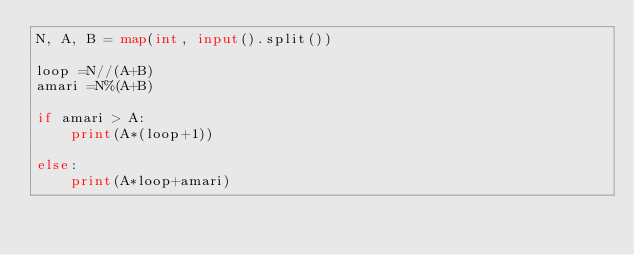Convert code to text. <code><loc_0><loc_0><loc_500><loc_500><_Python_>N, A, B = map(int, input().split())

loop =N//(A+B)
amari =N%(A+B)

if amari > A:
    print(A*(loop+1))

else:
    print(A*loop+amari)</code> 